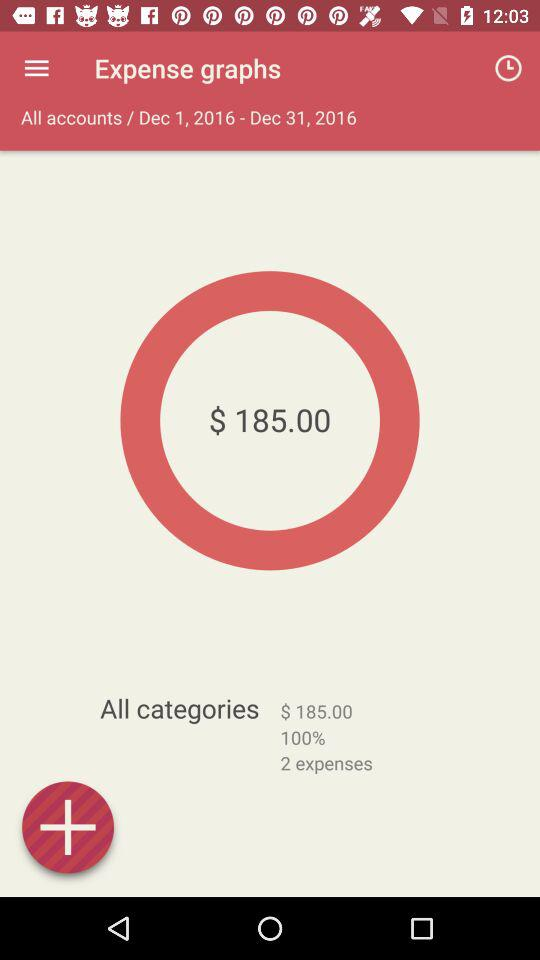How many expenses are in this report?
Answer the question using a single word or phrase. 2 